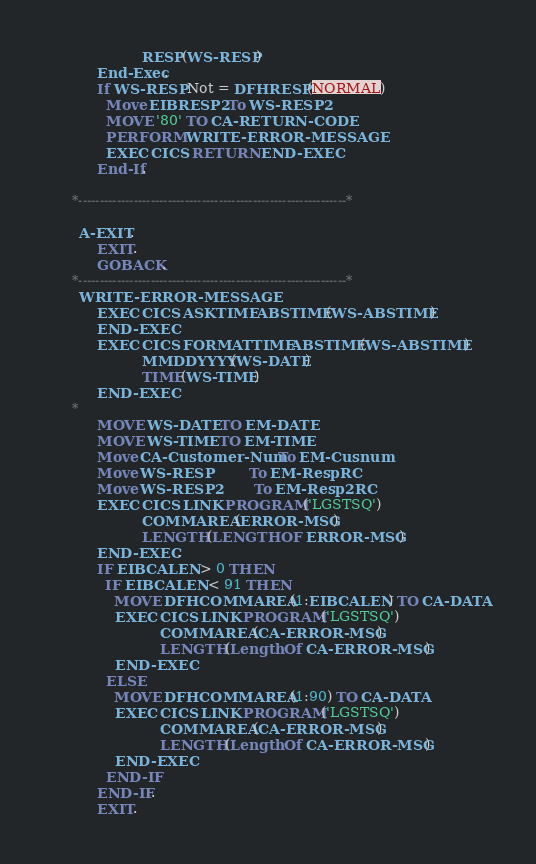Convert code to text. <code><loc_0><loc_0><loc_500><loc_500><_COBOL_>                     RESP(WS-RESP)
           End-Exec.
           If WS-RESP Not = DFHRESP(NORMAL)
             Move EIBRESP2 To WS-RESP2
             MOVE '80' TO CA-RETURN-CODE
             PERFORM WRITE-ERROR-MESSAGE
             EXEC CICS RETURN END-EXEC
           End-If.

      *---------------------------------------------------------------*

       A-EXIT.
           EXIT.
           GOBACK.
      *---------------------------------------------------------------*
       WRITE-ERROR-MESSAGE.
           EXEC CICS ASKTIME ABSTIME(WS-ABSTIME)
           END-EXEC
           EXEC CICS FORMATTIME ABSTIME(WS-ABSTIME)
                     MMDDYYYY(WS-DATE)
                     TIME(WS-TIME)
           END-EXEC
      *
           MOVE WS-DATE TO EM-DATE
           MOVE WS-TIME TO EM-TIME
           Move CA-Customer-Num To EM-Cusnum
           Move WS-RESP         To EM-RespRC
           Move WS-RESP2        To EM-Resp2RC
           EXEC CICS LINK PROGRAM('LGSTSQ')
                     COMMAREA(ERROR-MSG)
                     LENGTH(LENGTH OF ERROR-MSG)
           END-EXEC.
           IF EIBCALEN > 0 THEN
             IF EIBCALEN < 91 THEN
               MOVE DFHCOMMAREA(1:EIBCALEN) TO CA-DATA
               EXEC CICS LINK PROGRAM('LGSTSQ')
                         COMMAREA(CA-ERROR-MSG)
                         LENGTH(Length Of CA-ERROR-MSG)
               END-EXEC
             ELSE
               MOVE DFHCOMMAREA(1:90) TO CA-DATA
               EXEC CICS LINK PROGRAM('LGSTSQ')
                         COMMAREA(CA-ERROR-MSG)
                         LENGTH(Length Of CA-ERROR-MSG)
               END-EXEC
             END-IF
           END-IF.
           EXIT.
</code> 